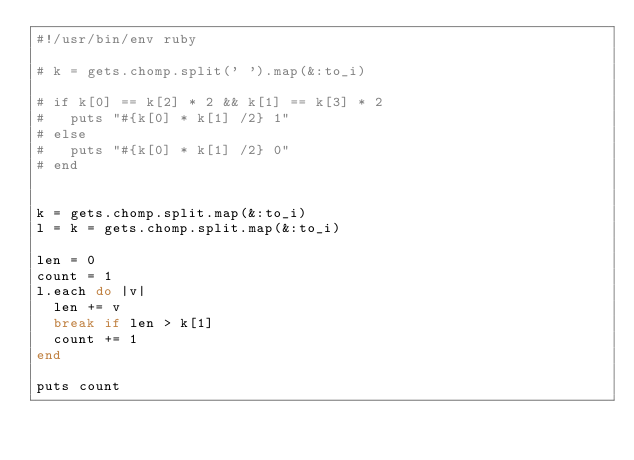Convert code to text. <code><loc_0><loc_0><loc_500><loc_500><_Ruby_>#!/usr/bin/env ruby

# k = gets.chomp.split(' ').map(&:to_i)

# if k[0] == k[2] * 2 && k[1] == k[3] * 2
#   puts "#{k[0] * k[1] /2} 1"
# else
#   puts "#{k[0] * k[1] /2} 0"
# end


k = gets.chomp.split.map(&:to_i)
l = k = gets.chomp.split.map(&:to_i)

len = 0
count = 1
l.each do |v|
  len += v
  break if len > k[1]
  count += 1
end

puts count</code> 